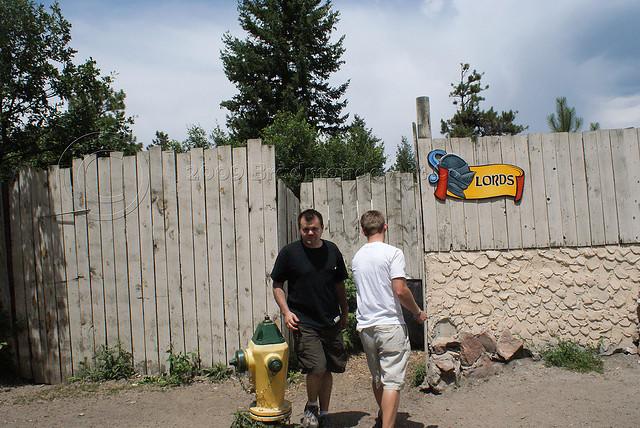What is the color of the hydrant?
Answer briefly. Yellow. How many people are there?
Quick response, please. 2. What color of t shirts are they wearing?
Write a very short answer. Black and white. What is written on the sign on the fence?
Write a very short answer. Lords. 